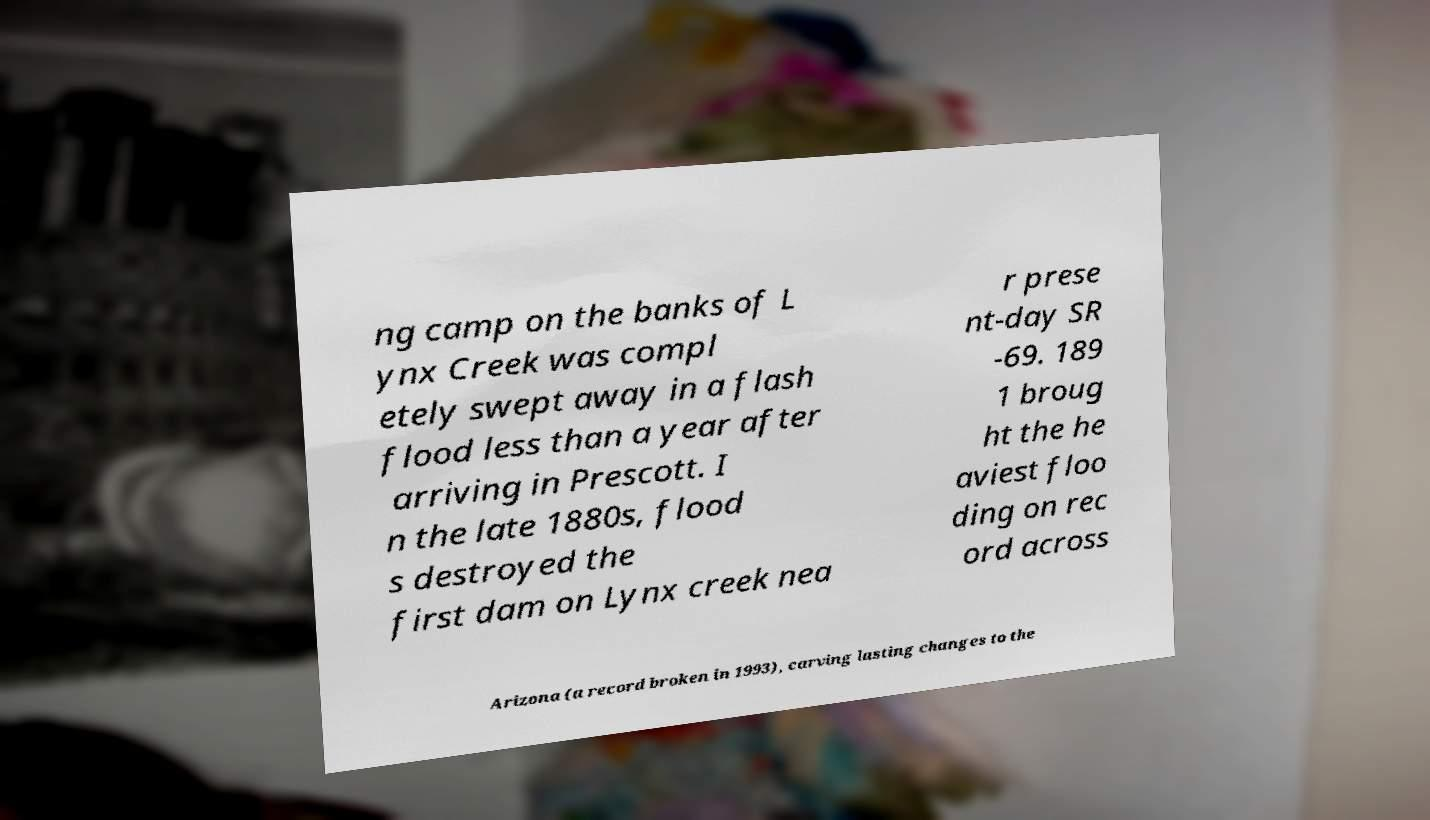There's text embedded in this image that I need extracted. Can you transcribe it verbatim? ng camp on the banks of L ynx Creek was compl etely swept away in a flash flood less than a year after arriving in Prescott. I n the late 1880s, flood s destroyed the first dam on Lynx creek nea r prese nt-day SR -69. 189 1 broug ht the he aviest floo ding on rec ord across Arizona (a record broken in 1993), carving lasting changes to the 